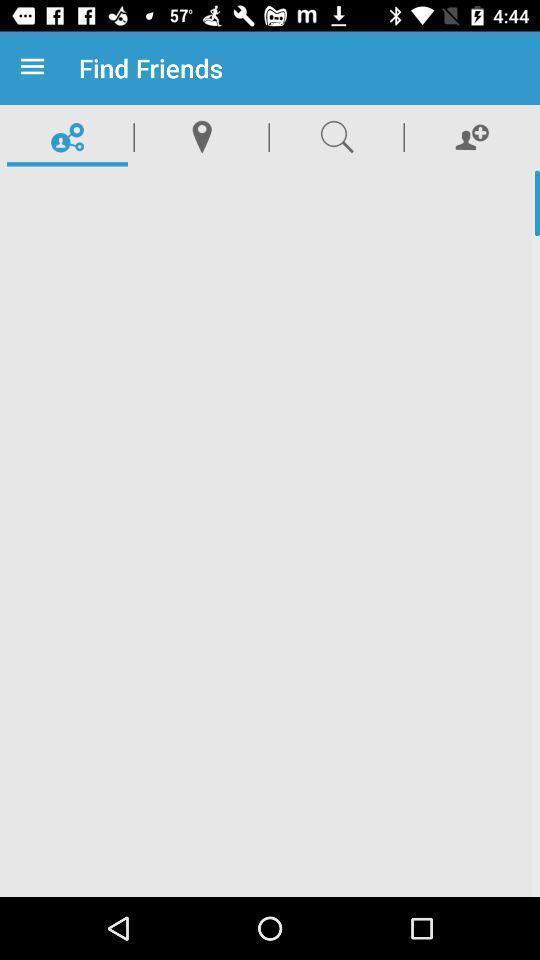Tell me what you see in this picture. Page showing different options. 